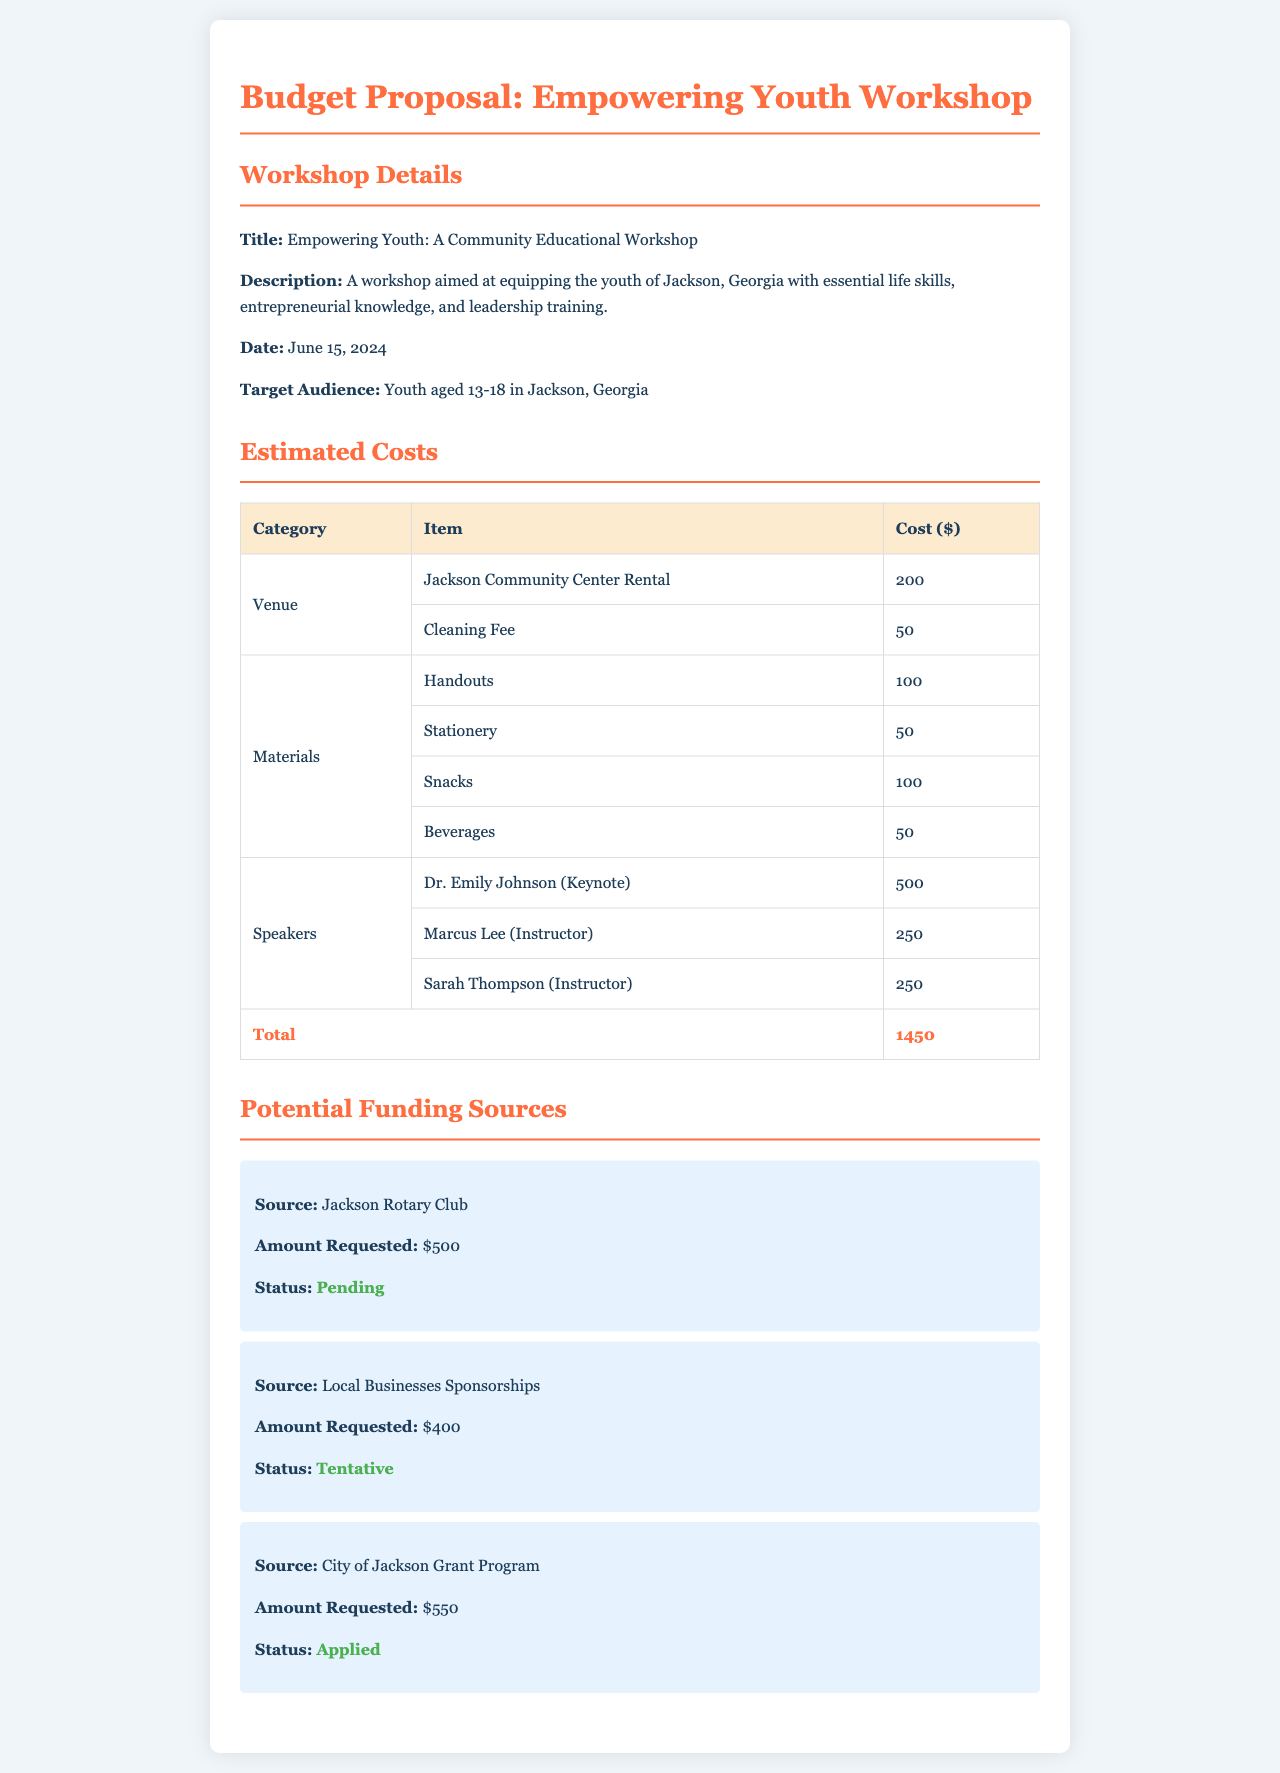What is the title of the workshop? The title of the workshop is specified in the document as "Empowering Youth: A Community Educational Workshop."
Answer: Empowering Youth: A Community Educational Workshop What is the total estimated cost for the workshop? The total estimated cost is calculated by adding all individual costs listed in the document, which sums up to $1450.
Answer: 1450 Who is the keynote speaker for the workshop? The document mentions Dr. Emily Johnson as the keynote speaker for the workshop.
Answer: Dr. Emily Johnson What is the amount requested from the City of Jackson Grant Program? The amount requested from the City of Jackson Grant Program can be found directly in the funding sources section, which states $550.
Answer: 550 How many types of materials are mentioned in the estimated costs? The document lists four types of materials under the estimated costs section: Handouts, Stationery, Snacks, and Beverages.
Answer: 4 What status is assigned to the funding request from the Jackson Rotary Club? The funding request from the Jackson Rotary Club is currently labeled as "Pending" in the document.
Answer: Pending What is the cleaning fee associated with the venue cost? The cleaning fee that is part of the venue costs is specified in the document as $50.
Answer: 50 How many speakers are listed in the estimated costs? The document lists three speakers under the estimated costs, namely Dr. Emily Johnson, Marcus Lee, and Sarah Thompson.
Answer: 3 What date is the workshop scheduled for? The scheduled date for the workshop is provided in the document as June 15, 2024.
Answer: June 15, 2024 